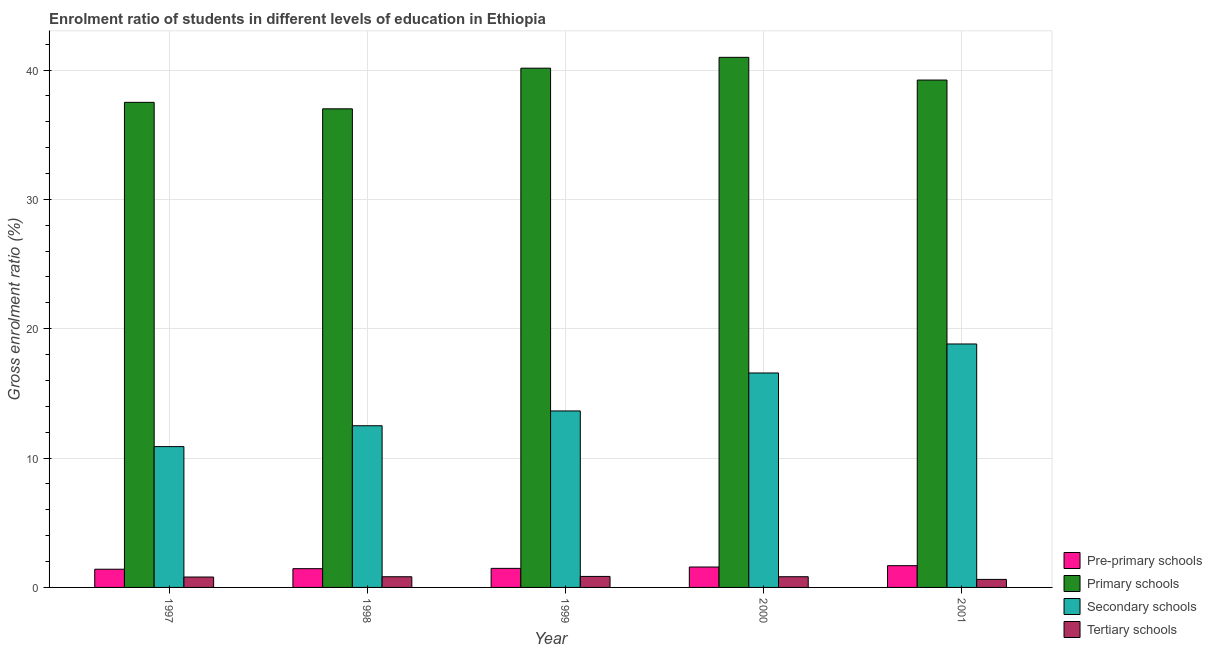How many different coloured bars are there?
Give a very brief answer. 4. How many groups of bars are there?
Keep it short and to the point. 5. Are the number of bars per tick equal to the number of legend labels?
Your response must be concise. Yes. How many bars are there on the 4th tick from the left?
Ensure brevity in your answer.  4. How many bars are there on the 5th tick from the right?
Your answer should be compact. 4. What is the gross enrolment ratio in tertiary schools in 1998?
Offer a very short reply. 0.83. Across all years, what is the maximum gross enrolment ratio in pre-primary schools?
Offer a very short reply. 1.68. Across all years, what is the minimum gross enrolment ratio in pre-primary schools?
Keep it short and to the point. 1.41. In which year was the gross enrolment ratio in secondary schools minimum?
Your answer should be very brief. 1997. What is the total gross enrolment ratio in primary schools in the graph?
Provide a succinct answer. 194.86. What is the difference between the gross enrolment ratio in primary schools in 1998 and that in 1999?
Provide a short and direct response. -3.14. What is the difference between the gross enrolment ratio in tertiary schools in 1997 and the gross enrolment ratio in primary schools in 2001?
Offer a very short reply. 0.18. What is the average gross enrolment ratio in primary schools per year?
Your answer should be very brief. 38.97. What is the ratio of the gross enrolment ratio in tertiary schools in 1998 to that in 2001?
Ensure brevity in your answer.  1.33. Is the difference between the gross enrolment ratio in tertiary schools in 1998 and 2001 greater than the difference between the gross enrolment ratio in primary schools in 1998 and 2001?
Offer a very short reply. No. What is the difference between the highest and the second highest gross enrolment ratio in primary schools?
Your answer should be very brief. 0.84. What is the difference between the highest and the lowest gross enrolment ratio in primary schools?
Your response must be concise. 3.98. Is the sum of the gross enrolment ratio in pre-primary schools in 1999 and 2001 greater than the maximum gross enrolment ratio in primary schools across all years?
Offer a terse response. Yes. Is it the case that in every year, the sum of the gross enrolment ratio in tertiary schools and gross enrolment ratio in pre-primary schools is greater than the sum of gross enrolment ratio in primary schools and gross enrolment ratio in secondary schools?
Your answer should be compact. No. What does the 1st bar from the left in 2000 represents?
Offer a terse response. Pre-primary schools. What does the 3rd bar from the right in 1999 represents?
Keep it short and to the point. Primary schools. Is it the case that in every year, the sum of the gross enrolment ratio in pre-primary schools and gross enrolment ratio in primary schools is greater than the gross enrolment ratio in secondary schools?
Offer a very short reply. Yes. How many years are there in the graph?
Provide a short and direct response. 5. What is the difference between two consecutive major ticks on the Y-axis?
Your answer should be very brief. 10. Are the values on the major ticks of Y-axis written in scientific E-notation?
Keep it short and to the point. No. Does the graph contain any zero values?
Provide a succinct answer. No. Where does the legend appear in the graph?
Ensure brevity in your answer.  Bottom right. How many legend labels are there?
Give a very brief answer. 4. How are the legend labels stacked?
Your response must be concise. Vertical. What is the title of the graph?
Keep it short and to the point. Enrolment ratio of students in different levels of education in Ethiopia. What is the label or title of the X-axis?
Provide a succinct answer. Year. What is the Gross enrolment ratio (%) in Pre-primary schools in 1997?
Give a very brief answer. 1.41. What is the Gross enrolment ratio (%) in Primary schools in 1997?
Offer a very short reply. 37.5. What is the Gross enrolment ratio (%) in Secondary schools in 1997?
Your answer should be very brief. 10.89. What is the Gross enrolment ratio (%) of Tertiary schools in 1997?
Provide a succinct answer. 0.8. What is the Gross enrolment ratio (%) in Pre-primary schools in 1998?
Keep it short and to the point. 1.45. What is the Gross enrolment ratio (%) in Primary schools in 1998?
Your answer should be compact. 37. What is the Gross enrolment ratio (%) of Secondary schools in 1998?
Give a very brief answer. 12.5. What is the Gross enrolment ratio (%) in Tertiary schools in 1998?
Your answer should be compact. 0.83. What is the Gross enrolment ratio (%) in Pre-primary schools in 1999?
Your answer should be compact. 1.47. What is the Gross enrolment ratio (%) of Primary schools in 1999?
Offer a terse response. 40.14. What is the Gross enrolment ratio (%) of Secondary schools in 1999?
Offer a very short reply. 13.64. What is the Gross enrolment ratio (%) of Tertiary schools in 1999?
Ensure brevity in your answer.  0.85. What is the Gross enrolment ratio (%) in Pre-primary schools in 2000?
Your answer should be compact. 1.58. What is the Gross enrolment ratio (%) in Primary schools in 2000?
Provide a short and direct response. 40.98. What is the Gross enrolment ratio (%) of Secondary schools in 2000?
Keep it short and to the point. 16.58. What is the Gross enrolment ratio (%) in Tertiary schools in 2000?
Provide a short and direct response. 0.83. What is the Gross enrolment ratio (%) of Pre-primary schools in 2001?
Provide a succinct answer. 1.68. What is the Gross enrolment ratio (%) in Primary schools in 2001?
Offer a very short reply. 39.23. What is the Gross enrolment ratio (%) of Secondary schools in 2001?
Keep it short and to the point. 18.82. What is the Gross enrolment ratio (%) of Tertiary schools in 2001?
Offer a terse response. 0.62. Across all years, what is the maximum Gross enrolment ratio (%) of Pre-primary schools?
Offer a terse response. 1.68. Across all years, what is the maximum Gross enrolment ratio (%) in Primary schools?
Give a very brief answer. 40.98. Across all years, what is the maximum Gross enrolment ratio (%) in Secondary schools?
Offer a terse response. 18.82. Across all years, what is the maximum Gross enrolment ratio (%) in Tertiary schools?
Offer a very short reply. 0.85. Across all years, what is the minimum Gross enrolment ratio (%) in Pre-primary schools?
Your answer should be compact. 1.41. Across all years, what is the minimum Gross enrolment ratio (%) in Primary schools?
Provide a short and direct response. 37. Across all years, what is the minimum Gross enrolment ratio (%) of Secondary schools?
Ensure brevity in your answer.  10.89. Across all years, what is the minimum Gross enrolment ratio (%) of Tertiary schools?
Your response must be concise. 0.62. What is the total Gross enrolment ratio (%) of Pre-primary schools in the graph?
Offer a terse response. 7.59. What is the total Gross enrolment ratio (%) in Primary schools in the graph?
Ensure brevity in your answer.  194.86. What is the total Gross enrolment ratio (%) of Secondary schools in the graph?
Ensure brevity in your answer.  72.43. What is the total Gross enrolment ratio (%) of Tertiary schools in the graph?
Offer a terse response. 3.93. What is the difference between the Gross enrolment ratio (%) of Pre-primary schools in 1997 and that in 1998?
Offer a very short reply. -0.04. What is the difference between the Gross enrolment ratio (%) in Primary schools in 1997 and that in 1998?
Provide a succinct answer. 0.5. What is the difference between the Gross enrolment ratio (%) in Secondary schools in 1997 and that in 1998?
Offer a very short reply. -1.61. What is the difference between the Gross enrolment ratio (%) in Tertiary schools in 1997 and that in 1998?
Keep it short and to the point. -0.02. What is the difference between the Gross enrolment ratio (%) in Pre-primary schools in 1997 and that in 1999?
Provide a succinct answer. -0.07. What is the difference between the Gross enrolment ratio (%) in Primary schools in 1997 and that in 1999?
Your response must be concise. -2.64. What is the difference between the Gross enrolment ratio (%) of Secondary schools in 1997 and that in 1999?
Your answer should be very brief. -2.76. What is the difference between the Gross enrolment ratio (%) in Tertiary schools in 1997 and that in 1999?
Your response must be concise. -0.05. What is the difference between the Gross enrolment ratio (%) in Pre-primary schools in 1997 and that in 2000?
Your response must be concise. -0.17. What is the difference between the Gross enrolment ratio (%) of Primary schools in 1997 and that in 2000?
Keep it short and to the point. -3.48. What is the difference between the Gross enrolment ratio (%) of Secondary schools in 1997 and that in 2000?
Provide a short and direct response. -5.69. What is the difference between the Gross enrolment ratio (%) in Tertiary schools in 1997 and that in 2000?
Offer a very short reply. -0.02. What is the difference between the Gross enrolment ratio (%) in Pre-primary schools in 1997 and that in 2001?
Offer a very short reply. -0.28. What is the difference between the Gross enrolment ratio (%) in Primary schools in 1997 and that in 2001?
Make the answer very short. -1.73. What is the difference between the Gross enrolment ratio (%) of Secondary schools in 1997 and that in 2001?
Provide a succinct answer. -7.93. What is the difference between the Gross enrolment ratio (%) in Tertiary schools in 1997 and that in 2001?
Offer a very short reply. 0.18. What is the difference between the Gross enrolment ratio (%) of Pre-primary schools in 1998 and that in 1999?
Provide a short and direct response. -0.02. What is the difference between the Gross enrolment ratio (%) in Primary schools in 1998 and that in 1999?
Your response must be concise. -3.14. What is the difference between the Gross enrolment ratio (%) of Secondary schools in 1998 and that in 1999?
Your answer should be compact. -1.14. What is the difference between the Gross enrolment ratio (%) of Tertiary schools in 1998 and that in 1999?
Your response must be concise. -0.02. What is the difference between the Gross enrolment ratio (%) in Pre-primary schools in 1998 and that in 2000?
Provide a short and direct response. -0.13. What is the difference between the Gross enrolment ratio (%) in Primary schools in 1998 and that in 2000?
Your answer should be very brief. -3.98. What is the difference between the Gross enrolment ratio (%) in Secondary schools in 1998 and that in 2000?
Your response must be concise. -4.08. What is the difference between the Gross enrolment ratio (%) in Tertiary schools in 1998 and that in 2000?
Provide a succinct answer. -0. What is the difference between the Gross enrolment ratio (%) of Pre-primary schools in 1998 and that in 2001?
Make the answer very short. -0.23. What is the difference between the Gross enrolment ratio (%) in Primary schools in 1998 and that in 2001?
Offer a terse response. -2.22. What is the difference between the Gross enrolment ratio (%) of Secondary schools in 1998 and that in 2001?
Make the answer very short. -6.32. What is the difference between the Gross enrolment ratio (%) of Tertiary schools in 1998 and that in 2001?
Ensure brevity in your answer.  0.21. What is the difference between the Gross enrolment ratio (%) in Pre-primary schools in 1999 and that in 2000?
Offer a very short reply. -0.1. What is the difference between the Gross enrolment ratio (%) in Primary schools in 1999 and that in 2000?
Provide a short and direct response. -0.84. What is the difference between the Gross enrolment ratio (%) in Secondary schools in 1999 and that in 2000?
Make the answer very short. -2.94. What is the difference between the Gross enrolment ratio (%) of Tertiary schools in 1999 and that in 2000?
Provide a short and direct response. 0.02. What is the difference between the Gross enrolment ratio (%) of Pre-primary schools in 1999 and that in 2001?
Your answer should be compact. -0.21. What is the difference between the Gross enrolment ratio (%) of Secondary schools in 1999 and that in 2001?
Give a very brief answer. -5.18. What is the difference between the Gross enrolment ratio (%) of Tertiary schools in 1999 and that in 2001?
Provide a short and direct response. 0.23. What is the difference between the Gross enrolment ratio (%) in Pre-primary schools in 2000 and that in 2001?
Offer a very short reply. -0.1. What is the difference between the Gross enrolment ratio (%) in Primary schools in 2000 and that in 2001?
Ensure brevity in your answer.  1.76. What is the difference between the Gross enrolment ratio (%) in Secondary schools in 2000 and that in 2001?
Ensure brevity in your answer.  -2.24. What is the difference between the Gross enrolment ratio (%) in Tertiary schools in 2000 and that in 2001?
Ensure brevity in your answer.  0.21. What is the difference between the Gross enrolment ratio (%) in Pre-primary schools in 1997 and the Gross enrolment ratio (%) in Primary schools in 1998?
Provide a short and direct response. -35.6. What is the difference between the Gross enrolment ratio (%) of Pre-primary schools in 1997 and the Gross enrolment ratio (%) of Secondary schools in 1998?
Give a very brief answer. -11.09. What is the difference between the Gross enrolment ratio (%) in Pre-primary schools in 1997 and the Gross enrolment ratio (%) in Tertiary schools in 1998?
Your answer should be very brief. 0.58. What is the difference between the Gross enrolment ratio (%) of Primary schools in 1997 and the Gross enrolment ratio (%) of Secondary schools in 1998?
Your answer should be compact. 25. What is the difference between the Gross enrolment ratio (%) of Primary schools in 1997 and the Gross enrolment ratio (%) of Tertiary schools in 1998?
Your response must be concise. 36.68. What is the difference between the Gross enrolment ratio (%) of Secondary schools in 1997 and the Gross enrolment ratio (%) of Tertiary schools in 1998?
Provide a short and direct response. 10.06. What is the difference between the Gross enrolment ratio (%) in Pre-primary schools in 1997 and the Gross enrolment ratio (%) in Primary schools in 1999?
Make the answer very short. -38.74. What is the difference between the Gross enrolment ratio (%) in Pre-primary schools in 1997 and the Gross enrolment ratio (%) in Secondary schools in 1999?
Your answer should be compact. -12.24. What is the difference between the Gross enrolment ratio (%) of Pre-primary schools in 1997 and the Gross enrolment ratio (%) of Tertiary schools in 1999?
Provide a succinct answer. 0.56. What is the difference between the Gross enrolment ratio (%) in Primary schools in 1997 and the Gross enrolment ratio (%) in Secondary schools in 1999?
Your response must be concise. 23.86. What is the difference between the Gross enrolment ratio (%) of Primary schools in 1997 and the Gross enrolment ratio (%) of Tertiary schools in 1999?
Make the answer very short. 36.65. What is the difference between the Gross enrolment ratio (%) of Secondary schools in 1997 and the Gross enrolment ratio (%) of Tertiary schools in 1999?
Your response must be concise. 10.04. What is the difference between the Gross enrolment ratio (%) of Pre-primary schools in 1997 and the Gross enrolment ratio (%) of Primary schools in 2000?
Provide a short and direct response. -39.58. What is the difference between the Gross enrolment ratio (%) in Pre-primary schools in 1997 and the Gross enrolment ratio (%) in Secondary schools in 2000?
Offer a terse response. -15.17. What is the difference between the Gross enrolment ratio (%) of Pre-primary schools in 1997 and the Gross enrolment ratio (%) of Tertiary schools in 2000?
Your response must be concise. 0.58. What is the difference between the Gross enrolment ratio (%) in Primary schools in 1997 and the Gross enrolment ratio (%) in Secondary schools in 2000?
Provide a succinct answer. 20.92. What is the difference between the Gross enrolment ratio (%) in Primary schools in 1997 and the Gross enrolment ratio (%) in Tertiary schools in 2000?
Offer a terse response. 36.67. What is the difference between the Gross enrolment ratio (%) of Secondary schools in 1997 and the Gross enrolment ratio (%) of Tertiary schools in 2000?
Your answer should be compact. 10.06. What is the difference between the Gross enrolment ratio (%) of Pre-primary schools in 1997 and the Gross enrolment ratio (%) of Primary schools in 2001?
Provide a succinct answer. -37.82. What is the difference between the Gross enrolment ratio (%) of Pre-primary schools in 1997 and the Gross enrolment ratio (%) of Secondary schools in 2001?
Your answer should be very brief. -17.42. What is the difference between the Gross enrolment ratio (%) in Pre-primary schools in 1997 and the Gross enrolment ratio (%) in Tertiary schools in 2001?
Your answer should be very brief. 0.79. What is the difference between the Gross enrolment ratio (%) of Primary schools in 1997 and the Gross enrolment ratio (%) of Secondary schools in 2001?
Make the answer very short. 18.68. What is the difference between the Gross enrolment ratio (%) of Primary schools in 1997 and the Gross enrolment ratio (%) of Tertiary schools in 2001?
Keep it short and to the point. 36.88. What is the difference between the Gross enrolment ratio (%) of Secondary schools in 1997 and the Gross enrolment ratio (%) of Tertiary schools in 2001?
Provide a short and direct response. 10.27. What is the difference between the Gross enrolment ratio (%) of Pre-primary schools in 1998 and the Gross enrolment ratio (%) of Primary schools in 1999?
Offer a very short reply. -38.69. What is the difference between the Gross enrolment ratio (%) of Pre-primary schools in 1998 and the Gross enrolment ratio (%) of Secondary schools in 1999?
Your response must be concise. -12.19. What is the difference between the Gross enrolment ratio (%) in Pre-primary schools in 1998 and the Gross enrolment ratio (%) in Tertiary schools in 1999?
Offer a very short reply. 0.6. What is the difference between the Gross enrolment ratio (%) in Primary schools in 1998 and the Gross enrolment ratio (%) in Secondary schools in 1999?
Make the answer very short. 23.36. What is the difference between the Gross enrolment ratio (%) of Primary schools in 1998 and the Gross enrolment ratio (%) of Tertiary schools in 1999?
Your answer should be compact. 36.15. What is the difference between the Gross enrolment ratio (%) of Secondary schools in 1998 and the Gross enrolment ratio (%) of Tertiary schools in 1999?
Offer a terse response. 11.65. What is the difference between the Gross enrolment ratio (%) of Pre-primary schools in 1998 and the Gross enrolment ratio (%) of Primary schools in 2000?
Ensure brevity in your answer.  -39.53. What is the difference between the Gross enrolment ratio (%) of Pre-primary schools in 1998 and the Gross enrolment ratio (%) of Secondary schools in 2000?
Your answer should be compact. -15.13. What is the difference between the Gross enrolment ratio (%) in Pre-primary schools in 1998 and the Gross enrolment ratio (%) in Tertiary schools in 2000?
Give a very brief answer. 0.62. What is the difference between the Gross enrolment ratio (%) in Primary schools in 1998 and the Gross enrolment ratio (%) in Secondary schools in 2000?
Offer a terse response. 20.42. What is the difference between the Gross enrolment ratio (%) in Primary schools in 1998 and the Gross enrolment ratio (%) in Tertiary schools in 2000?
Offer a terse response. 36.18. What is the difference between the Gross enrolment ratio (%) of Secondary schools in 1998 and the Gross enrolment ratio (%) of Tertiary schools in 2000?
Give a very brief answer. 11.67. What is the difference between the Gross enrolment ratio (%) in Pre-primary schools in 1998 and the Gross enrolment ratio (%) in Primary schools in 2001?
Your answer should be very brief. -37.78. What is the difference between the Gross enrolment ratio (%) in Pre-primary schools in 1998 and the Gross enrolment ratio (%) in Secondary schools in 2001?
Give a very brief answer. -17.37. What is the difference between the Gross enrolment ratio (%) in Pre-primary schools in 1998 and the Gross enrolment ratio (%) in Tertiary schools in 2001?
Your answer should be very brief. 0.83. What is the difference between the Gross enrolment ratio (%) in Primary schools in 1998 and the Gross enrolment ratio (%) in Secondary schools in 2001?
Offer a very short reply. 18.18. What is the difference between the Gross enrolment ratio (%) of Primary schools in 1998 and the Gross enrolment ratio (%) of Tertiary schools in 2001?
Make the answer very short. 36.38. What is the difference between the Gross enrolment ratio (%) of Secondary schools in 1998 and the Gross enrolment ratio (%) of Tertiary schools in 2001?
Make the answer very short. 11.88. What is the difference between the Gross enrolment ratio (%) of Pre-primary schools in 1999 and the Gross enrolment ratio (%) of Primary schools in 2000?
Ensure brevity in your answer.  -39.51. What is the difference between the Gross enrolment ratio (%) of Pre-primary schools in 1999 and the Gross enrolment ratio (%) of Secondary schools in 2000?
Give a very brief answer. -15.11. What is the difference between the Gross enrolment ratio (%) in Pre-primary schools in 1999 and the Gross enrolment ratio (%) in Tertiary schools in 2000?
Provide a succinct answer. 0.65. What is the difference between the Gross enrolment ratio (%) in Primary schools in 1999 and the Gross enrolment ratio (%) in Secondary schools in 2000?
Ensure brevity in your answer.  23.56. What is the difference between the Gross enrolment ratio (%) in Primary schools in 1999 and the Gross enrolment ratio (%) in Tertiary schools in 2000?
Offer a terse response. 39.32. What is the difference between the Gross enrolment ratio (%) of Secondary schools in 1999 and the Gross enrolment ratio (%) of Tertiary schools in 2000?
Keep it short and to the point. 12.82. What is the difference between the Gross enrolment ratio (%) of Pre-primary schools in 1999 and the Gross enrolment ratio (%) of Primary schools in 2001?
Offer a very short reply. -37.75. What is the difference between the Gross enrolment ratio (%) of Pre-primary schools in 1999 and the Gross enrolment ratio (%) of Secondary schools in 2001?
Provide a short and direct response. -17.35. What is the difference between the Gross enrolment ratio (%) in Pre-primary schools in 1999 and the Gross enrolment ratio (%) in Tertiary schools in 2001?
Your answer should be very brief. 0.85. What is the difference between the Gross enrolment ratio (%) in Primary schools in 1999 and the Gross enrolment ratio (%) in Secondary schools in 2001?
Offer a very short reply. 21.32. What is the difference between the Gross enrolment ratio (%) in Primary schools in 1999 and the Gross enrolment ratio (%) in Tertiary schools in 2001?
Offer a terse response. 39.52. What is the difference between the Gross enrolment ratio (%) of Secondary schools in 1999 and the Gross enrolment ratio (%) of Tertiary schools in 2001?
Your answer should be compact. 13.02. What is the difference between the Gross enrolment ratio (%) in Pre-primary schools in 2000 and the Gross enrolment ratio (%) in Primary schools in 2001?
Ensure brevity in your answer.  -37.65. What is the difference between the Gross enrolment ratio (%) in Pre-primary schools in 2000 and the Gross enrolment ratio (%) in Secondary schools in 2001?
Provide a short and direct response. -17.24. What is the difference between the Gross enrolment ratio (%) in Pre-primary schools in 2000 and the Gross enrolment ratio (%) in Tertiary schools in 2001?
Your response must be concise. 0.96. What is the difference between the Gross enrolment ratio (%) in Primary schools in 2000 and the Gross enrolment ratio (%) in Secondary schools in 2001?
Keep it short and to the point. 22.16. What is the difference between the Gross enrolment ratio (%) in Primary schools in 2000 and the Gross enrolment ratio (%) in Tertiary schools in 2001?
Offer a terse response. 40.36. What is the difference between the Gross enrolment ratio (%) of Secondary schools in 2000 and the Gross enrolment ratio (%) of Tertiary schools in 2001?
Make the answer very short. 15.96. What is the average Gross enrolment ratio (%) of Pre-primary schools per year?
Give a very brief answer. 1.52. What is the average Gross enrolment ratio (%) in Primary schools per year?
Your response must be concise. 38.97. What is the average Gross enrolment ratio (%) of Secondary schools per year?
Give a very brief answer. 14.49. What is the average Gross enrolment ratio (%) in Tertiary schools per year?
Offer a very short reply. 0.79. In the year 1997, what is the difference between the Gross enrolment ratio (%) of Pre-primary schools and Gross enrolment ratio (%) of Primary schools?
Offer a terse response. -36.09. In the year 1997, what is the difference between the Gross enrolment ratio (%) in Pre-primary schools and Gross enrolment ratio (%) in Secondary schools?
Provide a succinct answer. -9.48. In the year 1997, what is the difference between the Gross enrolment ratio (%) in Pre-primary schools and Gross enrolment ratio (%) in Tertiary schools?
Provide a short and direct response. 0.6. In the year 1997, what is the difference between the Gross enrolment ratio (%) in Primary schools and Gross enrolment ratio (%) in Secondary schools?
Ensure brevity in your answer.  26.61. In the year 1997, what is the difference between the Gross enrolment ratio (%) in Primary schools and Gross enrolment ratio (%) in Tertiary schools?
Offer a terse response. 36.7. In the year 1997, what is the difference between the Gross enrolment ratio (%) of Secondary schools and Gross enrolment ratio (%) of Tertiary schools?
Provide a short and direct response. 10.08. In the year 1998, what is the difference between the Gross enrolment ratio (%) of Pre-primary schools and Gross enrolment ratio (%) of Primary schools?
Your answer should be very brief. -35.55. In the year 1998, what is the difference between the Gross enrolment ratio (%) of Pre-primary schools and Gross enrolment ratio (%) of Secondary schools?
Make the answer very short. -11.05. In the year 1998, what is the difference between the Gross enrolment ratio (%) in Pre-primary schools and Gross enrolment ratio (%) in Tertiary schools?
Provide a succinct answer. 0.62. In the year 1998, what is the difference between the Gross enrolment ratio (%) in Primary schools and Gross enrolment ratio (%) in Secondary schools?
Your answer should be compact. 24.5. In the year 1998, what is the difference between the Gross enrolment ratio (%) of Primary schools and Gross enrolment ratio (%) of Tertiary schools?
Offer a very short reply. 36.18. In the year 1998, what is the difference between the Gross enrolment ratio (%) of Secondary schools and Gross enrolment ratio (%) of Tertiary schools?
Your answer should be compact. 11.67. In the year 1999, what is the difference between the Gross enrolment ratio (%) of Pre-primary schools and Gross enrolment ratio (%) of Primary schools?
Your answer should be very brief. -38.67. In the year 1999, what is the difference between the Gross enrolment ratio (%) of Pre-primary schools and Gross enrolment ratio (%) of Secondary schools?
Offer a very short reply. -12.17. In the year 1999, what is the difference between the Gross enrolment ratio (%) in Pre-primary schools and Gross enrolment ratio (%) in Tertiary schools?
Give a very brief answer. 0.62. In the year 1999, what is the difference between the Gross enrolment ratio (%) of Primary schools and Gross enrolment ratio (%) of Secondary schools?
Provide a short and direct response. 26.5. In the year 1999, what is the difference between the Gross enrolment ratio (%) of Primary schools and Gross enrolment ratio (%) of Tertiary schools?
Provide a succinct answer. 39.29. In the year 1999, what is the difference between the Gross enrolment ratio (%) of Secondary schools and Gross enrolment ratio (%) of Tertiary schools?
Provide a short and direct response. 12.79. In the year 2000, what is the difference between the Gross enrolment ratio (%) in Pre-primary schools and Gross enrolment ratio (%) in Primary schools?
Give a very brief answer. -39.4. In the year 2000, what is the difference between the Gross enrolment ratio (%) in Pre-primary schools and Gross enrolment ratio (%) in Secondary schools?
Give a very brief answer. -15. In the year 2000, what is the difference between the Gross enrolment ratio (%) of Pre-primary schools and Gross enrolment ratio (%) of Tertiary schools?
Your answer should be very brief. 0.75. In the year 2000, what is the difference between the Gross enrolment ratio (%) of Primary schools and Gross enrolment ratio (%) of Secondary schools?
Keep it short and to the point. 24.4. In the year 2000, what is the difference between the Gross enrolment ratio (%) in Primary schools and Gross enrolment ratio (%) in Tertiary schools?
Provide a short and direct response. 40.16. In the year 2000, what is the difference between the Gross enrolment ratio (%) of Secondary schools and Gross enrolment ratio (%) of Tertiary schools?
Give a very brief answer. 15.75. In the year 2001, what is the difference between the Gross enrolment ratio (%) in Pre-primary schools and Gross enrolment ratio (%) in Primary schools?
Offer a very short reply. -37.54. In the year 2001, what is the difference between the Gross enrolment ratio (%) in Pre-primary schools and Gross enrolment ratio (%) in Secondary schools?
Offer a terse response. -17.14. In the year 2001, what is the difference between the Gross enrolment ratio (%) of Pre-primary schools and Gross enrolment ratio (%) of Tertiary schools?
Ensure brevity in your answer.  1.06. In the year 2001, what is the difference between the Gross enrolment ratio (%) in Primary schools and Gross enrolment ratio (%) in Secondary schools?
Offer a terse response. 20.41. In the year 2001, what is the difference between the Gross enrolment ratio (%) in Primary schools and Gross enrolment ratio (%) in Tertiary schools?
Provide a short and direct response. 38.61. In the year 2001, what is the difference between the Gross enrolment ratio (%) in Secondary schools and Gross enrolment ratio (%) in Tertiary schools?
Make the answer very short. 18.2. What is the ratio of the Gross enrolment ratio (%) of Pre-primary schools in 1997 to that in 1998?
Ensure brevity in your answer.  0.97. What is the ratio of the Gross enrolment ratio (%) of Primary schools in 1997 to that in 1998?
Offer a terse response. 1.01. What is the ratio of the Gross enrolment ratio (%) in Secondary schools in 1997 to that in 1998?
Provide a short and direct response. 0.87. What is the ratio of the Gross enrolment ratio (%) of Tertiary schools in 1997 to that in 1998?
Provide a short and direct response. 0.97. What is the ratio of the Gross enrolment ratio (%) of Pre-primary schools in 1997 to that in 1999?
Ensure brevity in your answer.  0.95. What is the ratio of the Gross enrolment ratio (%) of Primary schools in 1997 to that in 1999?
Offer a terse response. 0.93. What is the ratio of the Gross enrolment ratio (%) in Secondary schools in 1997 to that in 1999?
Provide a succinct answer. 0.8. What is the ratio of the Gross enrolment ratio (%) of Tertiary schools in 1997 to that in 1999?
Provide a short and direct response. 0.95. What is the ratio of the Gross enrolment ratio (%) of Pre-primary schools in 1997 to that in 2000?
Make the answer very short. 0.89. What is the ratio of the Gross enrolment ratio (%) in Primary schools in 1997 to that in 2000?
Offer a terse response. 0.92. What is the ratio of the Gross enrolment ratio (%) in Secondary schools in 1997 to that in 2000?
Give a very brief answer. 0.66. What is the ratio of the Gross enrolment ratio (%) in Tertiary schools in 1997 to that in 2000?
Your response must be concise. 0.97. What is the ratio of the Gross enrolment ratio (%) of Pre-primary schools in 1997 to that in 2001?
Provide a succinct answer. 0.84. What is the ratio of the Gross enrolment ratio (%) of Primary schools in 1997 to that in 2001?
Provide a succinct answer. 0.96. What is the ratio of the Gross enrolment ratio (%) in Secondary schools in 1997 to that in 2001?
Offer a terse response. 0.58. What is the ratio of the Gross enrolment ratio (%) of Tertiary schools in 1997 to that in 2001?
Provide a short and direct response. 1.3. What is the ratio of the Gross enrolment ratio (%) in Pre-primary schools in 1998 to that in 1999?
Your response must be concise. 0.98. What is the ratio of the Gross enrolment ratio (%) of Primary schools in 1998 to that in 1999?
Keep it short and to the point. 0.92. What is the ratio of the Gross enrolment ratio (%) in Secondary schools in 1998 to that in 1999?
Your answer should be very brief. 0.92. What is the ratio of the Gross enrolment ratio (%) in Tertiary schools in 1998 to that in 1999?
Make the answer very short. 0.97. What is the ratio of the Gross enrolment ratio (%) in Pre-primary schools in 1998 to that in 2000?
Give a very brief answer. 0.92. What is the ratio of the Gross enrolment ratio (%) in Primary schools in 1998 to that in 2000?
Offer a very short reply. 0.9. What is the ratio of the Gross enrolment ratio (%) of Secondary schools in 1998 to that in 2000?
Offer a very short reply. 0.75. What is the ratio of the Gross enrolment ratio (%) of Tertiary schools in 1998 to that in 2000?
Keep it short and to the point. 1. What is the ratio of the Gross enrolment ratio (%) of Pre-primary schools in 1998 to that in 2001?
Ensure brevity in your answer.  0.86. What is the ratio of the Gross enrolment ratio (%) of Primary schools in 1998 to that in 2001?
Provide a short and direct response. 0.94. What is the ratio of the Gross enrolment ratio (%) of Secondary schools in 1998 to that in 2001?
Your answer should be compact. 0.66. What is the ratio of the Gross enrolment ratio (%) in Tertiary schools in 1998 to that in 2001?
Provide a short and direct response. 1.33. What is the ratio of the Gross enrolment ratio (%) of Pre-primary schools in 1999 to that in 2000?
Make the answer very short. 0.93. What is the ratio of the Gross enrolment ratio (%) in Primary schools in 1999 to that in 2000?
Provide a succinct answer. 0.98. What is the ratio of the Gross enrolment ratio (%) of Secondary schools in 1999 to that in 2000?
Your answer should be very brief. 0.82. What is the ratio of the Gross enrolment ratio (%) in Tertiary schools in 1999 to that in 2000?
Provide a succinct answer. 1.03. What is the ratio of the Gross enrolment ratio (%) of Pre-primary schools in 1999 to that in 2001?
Ensure brevity in your answer.  0.88. What is the ratio of the Gross enrolment ratio (%) in Primary schools in 1999 to that in 2001?
Offer a very short reply. 1.02. What is the ratio of the Gross enrolment ratio (%) of Secondary schools in 1999 to that in 2001?
Your response must be concise. 0.72. What is the ratio of the Gross enrolment ratio (%) in Tertiary schools in 1999 to that in 2001?
Offer a very short reply. 1.37. What is the ratio of the Gross enrolment ratio (%) in Pre-primary schools in 2000 to that in 2001?
Ensure brevity in your answer.  0.94. What is the ratio of the Gross enrolment ratio (%) of Primary schools in 2000 to that in 2001?
Provide a succinct answer. 1.04. What is the ratio of the Gross enrolment ratio (%) of Secondary schools in 2000 to that in 2001?
Offer a very short reply. 0.88. What is the ratio of the Gross enrolment ratio (%) in Tertiary schools in 2000 to that in 2001?
Provide a succinct answer. 1.33. What is the difference between the highest and the second highest Gross enrolment ratio (%) in Pre-primary schools?
Give a very brief answer. 0.1. What is the difference between the highest and the second highest Gross enrolment ratio (%) in Primary schools?
Your answer should be very brief. 0.84. What is the difference between the highest and the second highest Gross enrolment ratio (%) of Secondary schools?
Offer a terse response. 2.24. What is the difference between the highest and the second highest Gross enrolment ratio (%) in Tertiary schools?
Make the answer very short. 0.02. What is the difference between the highest and the lowest Gross enrolment ratio (%) in Pre-primary schools?
Your answer should be compact. 0.28. What is the difference between the highest and the lowest Gross enrolment ratio (%) of Primary schools?
Keep it short and to the point. 3.98. What is the difference between the highest and the lowest Gross enrolment ratio (%) in Secondary schools?
Provide a short and direct response. 7.93. What is the difference between the highest and the lowest Gross enrolment ratio (%) of Tertiary schools?
Give a very brief answer. 0.23. 